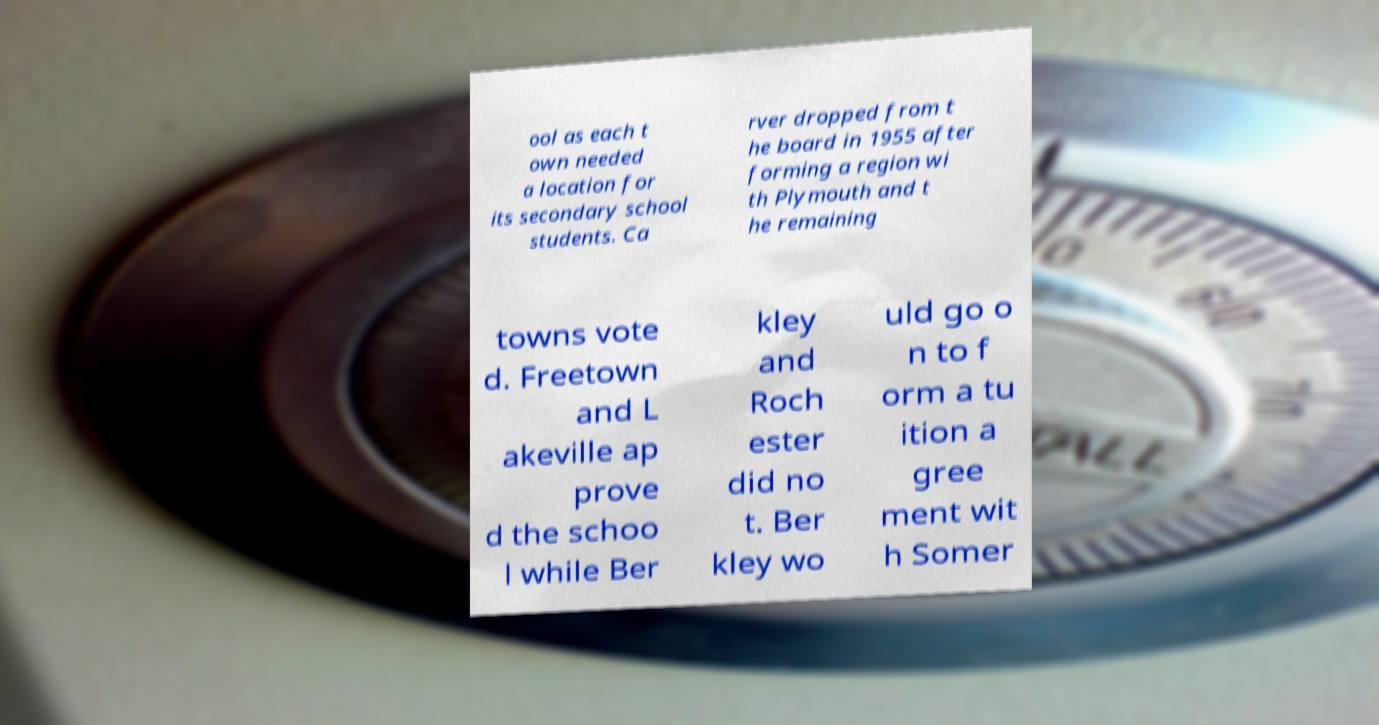I need the written content from this picture converted into text. Can you do that? ool as each t own needed a location for its secondary school students. Ca rver dropped from t he board in 1955 after forming a region wi th Plymouth and t he remaining towns vote d. Freetown and L akeville ap prove d the schoo l while Ber kley and Roch ester did no t. Ber kley wo uld go o n to f orm a tu ition a gree ment wit h Somer 